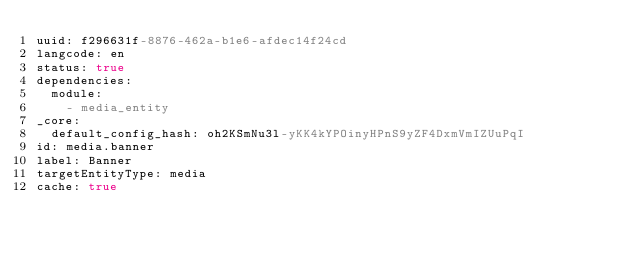<code> <loc_0><loc_0><loc_500><loc_500><_YAML_>uuid: f296631f-8876-462a-b1e6-afdec14f24cd
langcode: en
status: true
dependencies:
  module:
    - media_entity
_core:
  default_config_hash: oh2KSmNu3l-yKK4kYPOinyHPnS9yZF4DxmVmIZUuPqI
id: media.banner
label: Banner
targetEntityType: media
cache: true
</code> 